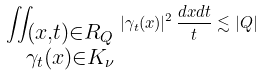<formula> <loc_0><loc_0><loc_500><loc_500>\iint _ { \substack { ( x , t ) \in R _ { Q } \\ \gamma _ { t } ( x ) \in K _ { \nu } } } | \gamma _ { t } ( x ) | ^ { 2 } \, \frac { d x d t } { t } \lesssim | Q |</formula> 